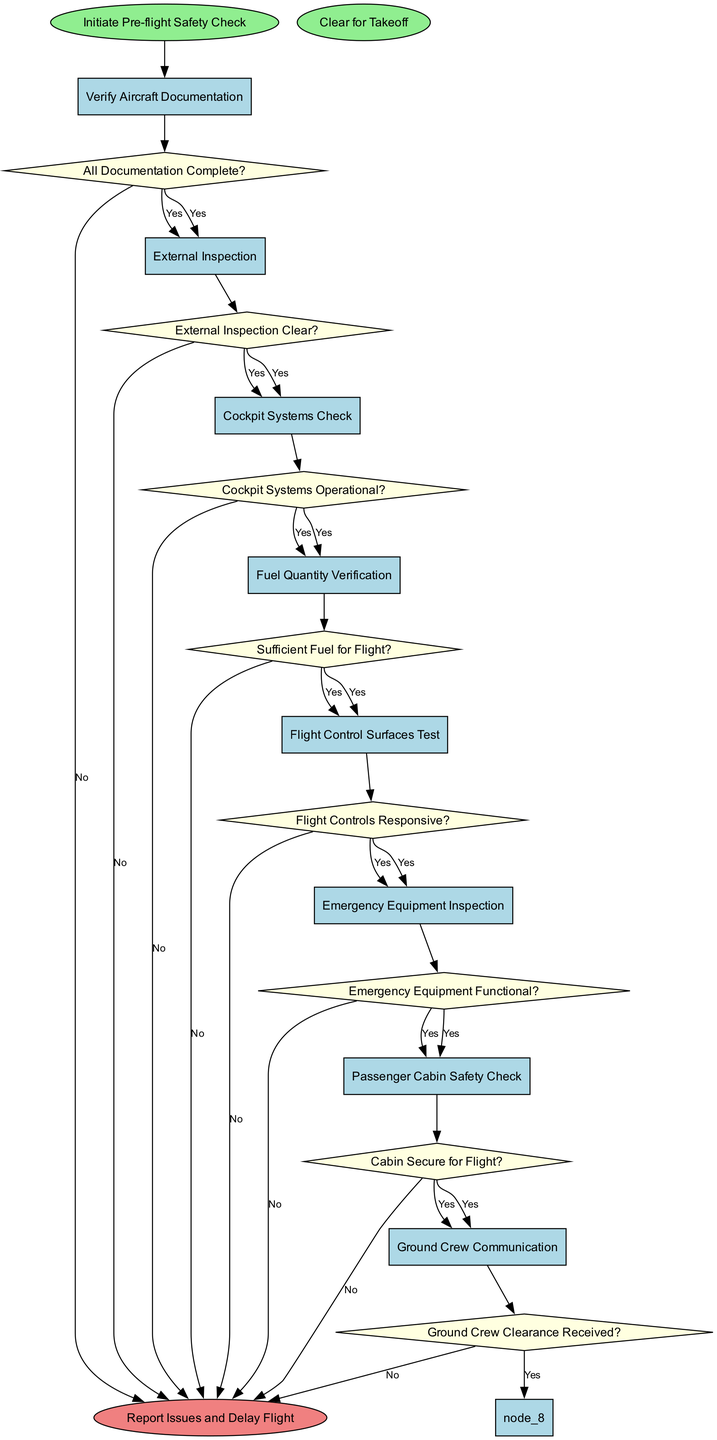What is the starting point of the flowchart? The starting point of the flowchart is indicated by the 'start' node, which is labeled "Initiate Pre-flight Safety Check".
Answer: Initiate Pre-flight Safety Check How many nodes are there in total? The diagram contains a total of 9 nodes: 8 process nodes and 1 start node.
Answer: 9 What is the final node in the flowchart? The final node labeled in the flowchart indicates that the process concludes with "Clear for Takeoff".
Answer: Clear for Takeoff What decision follows the "Emergency Equipment Inspection"? The decision that follows this process node is "Emergency Equipment Functional?".
Answer: Emergency Equipment Functional? What happens if a decision results in 'No'? If any decision results in 'No', the subsequent action is to "Report Issues and Delay Flight".
Answer: Report Issues and Delay Flight Which node requires confirmation of sufficient fuel? The node that specifically checks for sufficient fuel is labeled "Fuel Quantity Verification".
Answer: Fuel Quantity Verification What is the relationship between "Cockpit Systems Check" and "All Documentation Complete?" The "Cockpit Systems Check" is preceded by the decision "All Documentation Complete?" and is connected to it, indicating that if documentation is complete, the process moves on to cockpit checks.
Answer: Preceded by What is the sequence order for the first three nodes in the flowchart? The first three nodes in the flowchart are "Verify Aircraft Documentation", "External Inspection", and "Cockpit Systems Check", which follow in that order after the start node.
Answer: Verify Aircraft Documentation, External Inspection, Cockpit Systems Check What does the "Final Systems Review" node require clearance from? The "Final Systems Review" node requires clearance indicated by "Ground Crew Clearance Received?".
Answer: Ground Crew Clearance Received? 